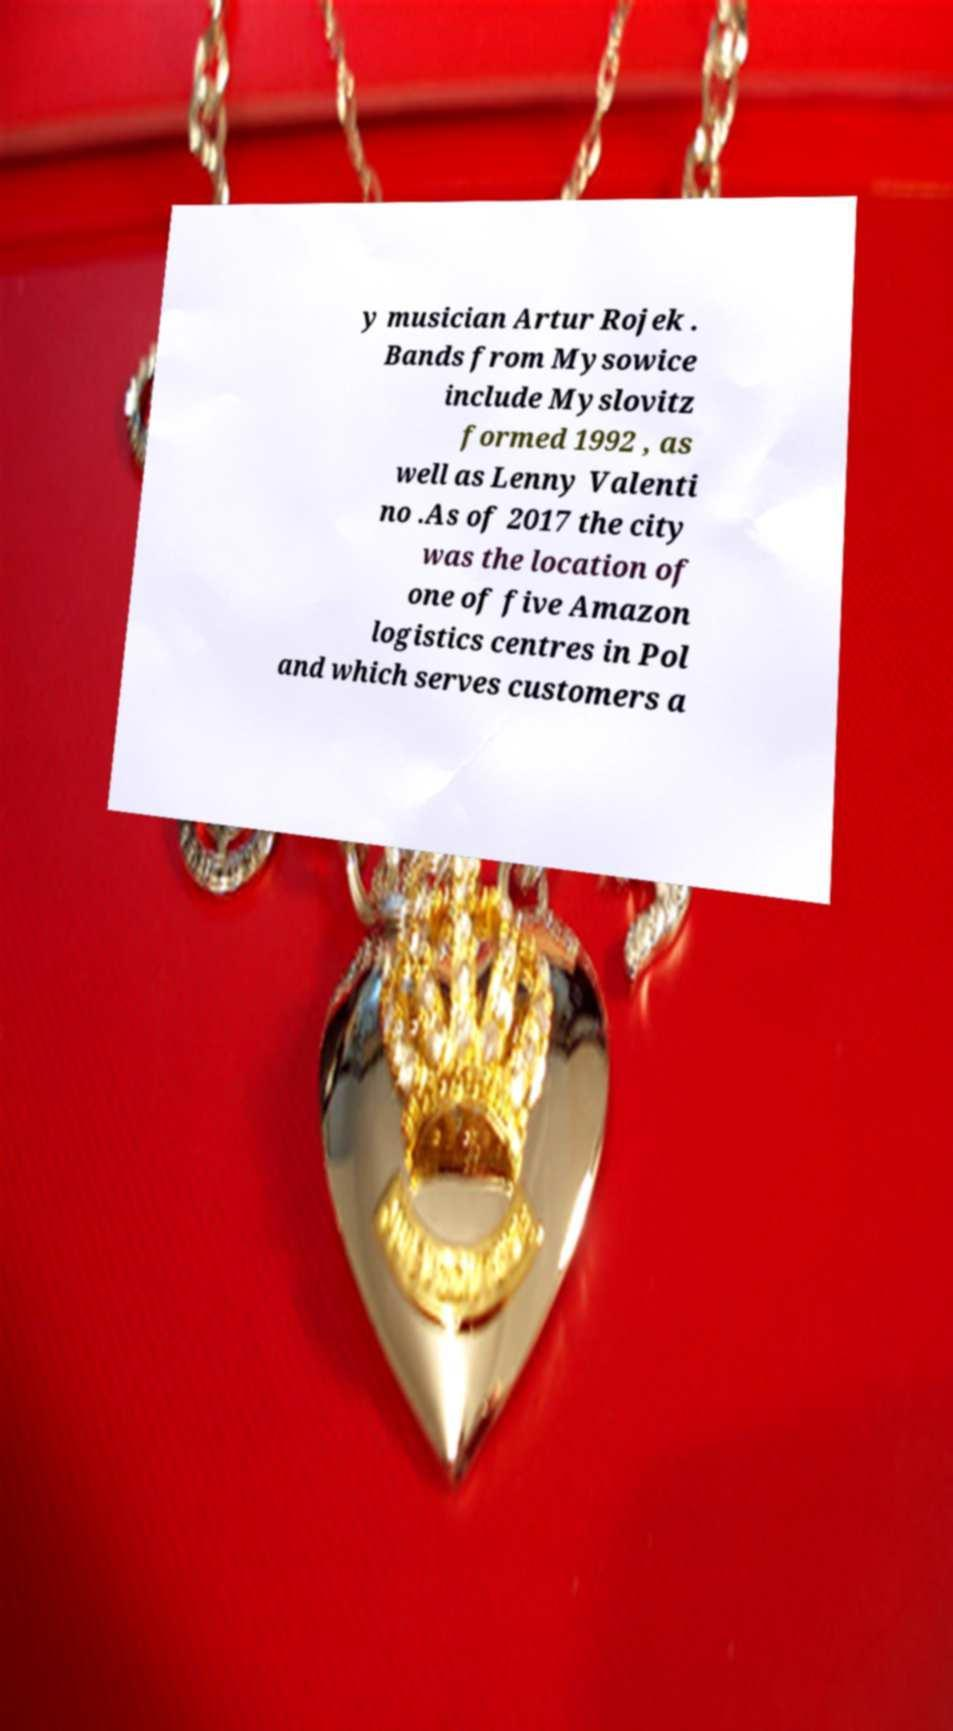For documentation purposes, I need the text within this image transcribed. Could you provide that? y musician Artur Rojek . Bands from Mysowice include Myslovitz formed 1992 , as well as Lenny Valenti no .As of 2017 the city was the location of one of five Amazon logistics centres in Pol and which serves customers a 